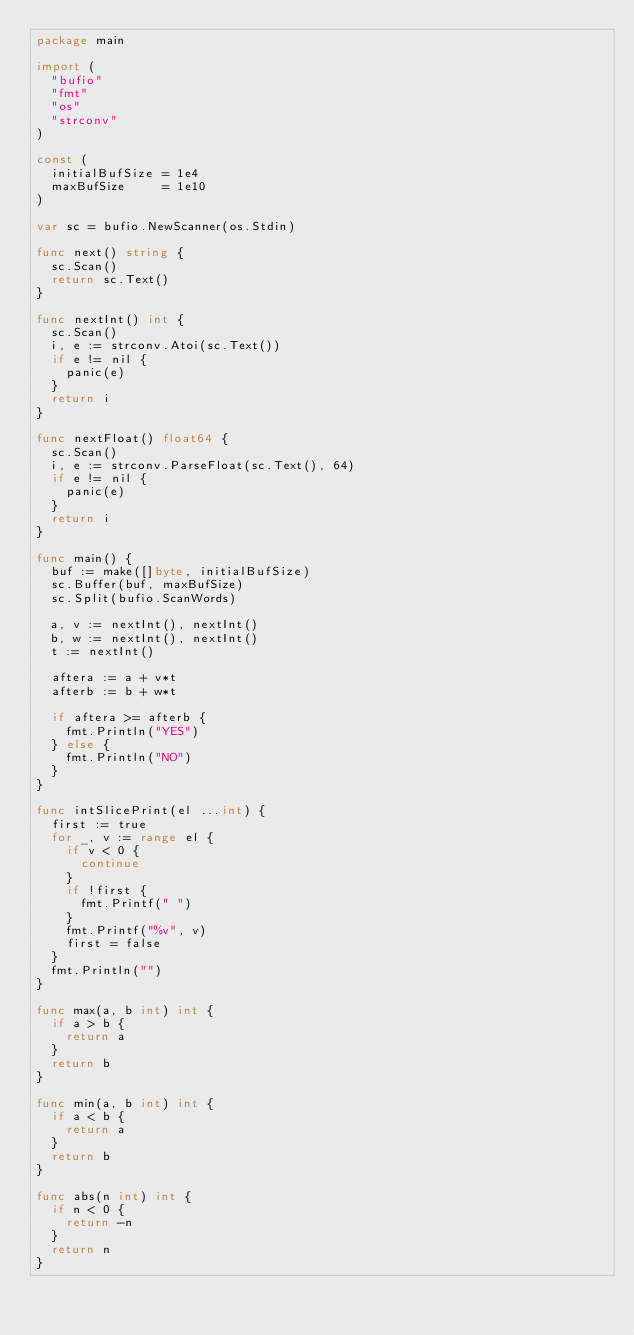<code> <loc_0><loc_0><loc_500><loc_500><_Go_>package main

import (
	"bufio"
	"fmt"
	"os"
	"strconv"
)

const (
	initialBufSize = 1e4
	maxBufSize     = 1e10
)

var sc = bufio.NewScanner(os.Stdin)

func next() string {
	sc.Scan()
	return sc.Text()
}

func nextInt() int {
	sc.Scan()
	i, e := strconv.Atoi(sc.Text())
	if e != nil {
		panic(e)
	}
	return i
}

func nextFloat() float64 {
	sc.Scan()
	i, e := strconv.ParseFloat(sc.Text(), 64)
	if e != nil {
		panic(e)
	}
	return i
}

func main() {
	buf := make([]byte, initialBufSize)
	sc.Buffer(buf, maxBufSize)
	sc.Split(bufio.ScanWords)

	a, v := nextInt(), nextInt()
	b, w := nextInt(), nextInt()
	t := nextInt()

	aftera := a + v*t
	afterb := b + w*t

	if aftera >= afterb {
		fmt.Println("YES")
	} else {
		fmt.Println("NO")
	}
}

func intSlicePrint(el ...int) {
	first := true
	for _, v := range el {
		if v < 0 {
			continue
		}
		if !first {
			fmt.Printf(" ")
		}
		fmt.Printf("%v", v)
		first = false
	}
	fmt.Println("")
}

func max(a, b int) int {
	if a > b {
		return a
	}
	return b
}

func min(a, b int) int {
	if a < b {
		return a
	}
	return b
}

func abs(n int) int {
	if n < 0 {
		return -n
	}
	return n
}
</code> 